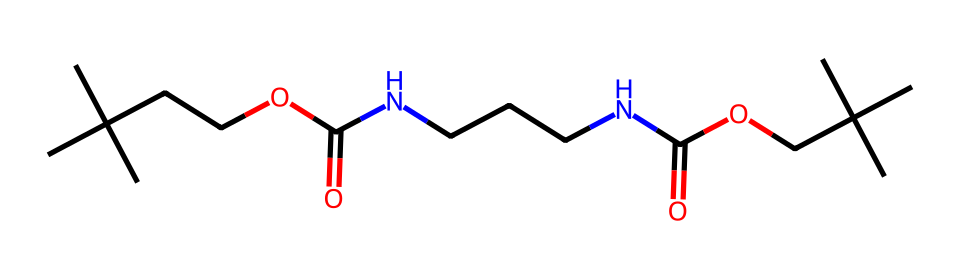What is the main functional group present in this chemical? The chemical contains both an ester (from the carbonyl and -O- linkage) and an amide group (from the carbonyl and -N- linkage). Generally, the presence of -COO- indicates the ester functional group. Therefore, the main functional group is ester.
Answer: ester How many nitrogen atoms are in the structure? By analyzing the SMILES representation, there are two nitrogen atoms present (NCCCNC), indicating that the polymer has both amide linkages and nitrogen-containing segments.
Answer: 2 What type of polymer does this chemical represent? The chemical structure includes urethane linkages (due to the presence of -OC(=O)N-), which is characteristic of polyurethane polymers. This makes it a type of polymer that is typically used in foam applications.
Answer: polyurethane What is the total number of carbon atoms in the chemical? By breaking down the SMILES representation, we count a total of 14 carbon atoms (C's) in the structure, which contribute to both the backbone and functional groups.
Answer: 14 What kind of intermolecular forces are primarily present in polyurethane foam? Polyurethane foam exhibits significant hydrogen bonding due to the presence of amide groups, as well as van der Waals forces from the long hydrocarbon chains. This enhances its stability and form.
Answer: hydrogen bonding 